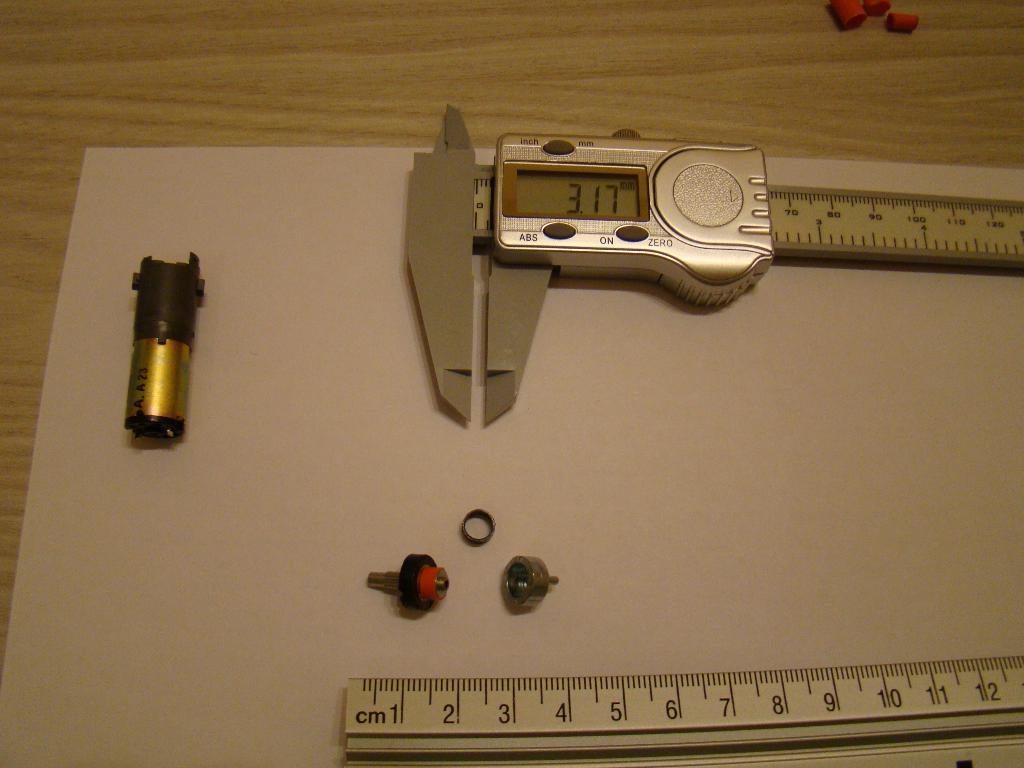What is written on the object on the left?
Provide a short and direct response. A.a23. What numbers are on the clipper?
Your answer should be compact. 3.17. 